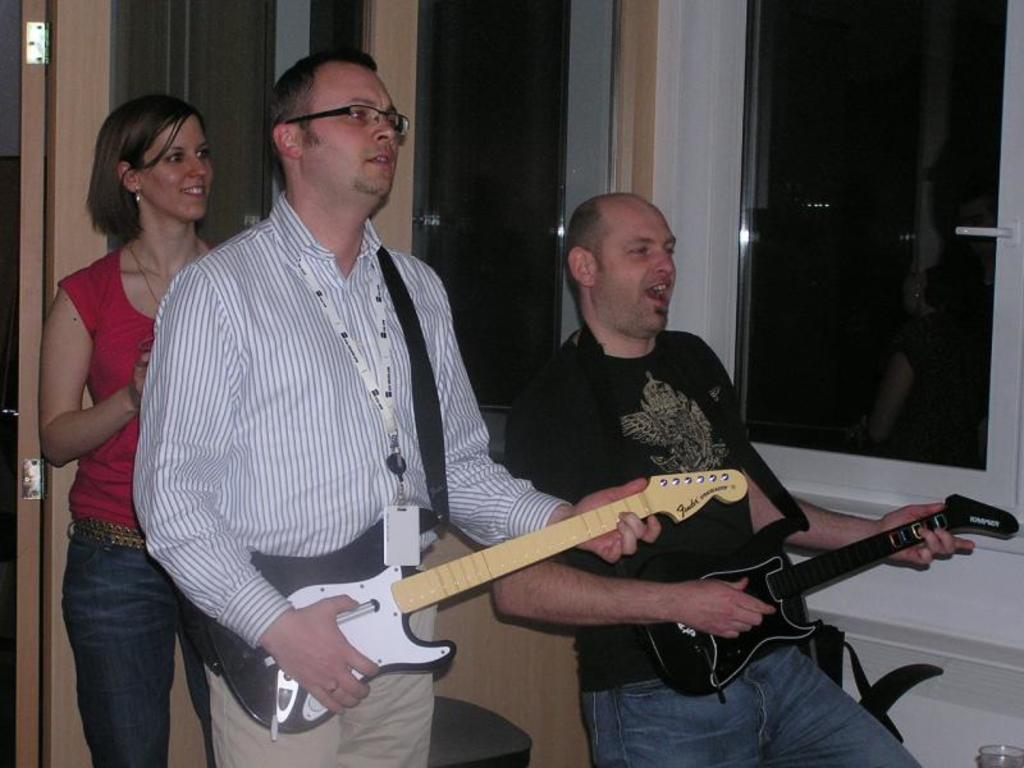Please provide a concise description of this image. This picture shows two men Standing and playing guitar holding in their hands and we see a woman standing with a smile on her face 